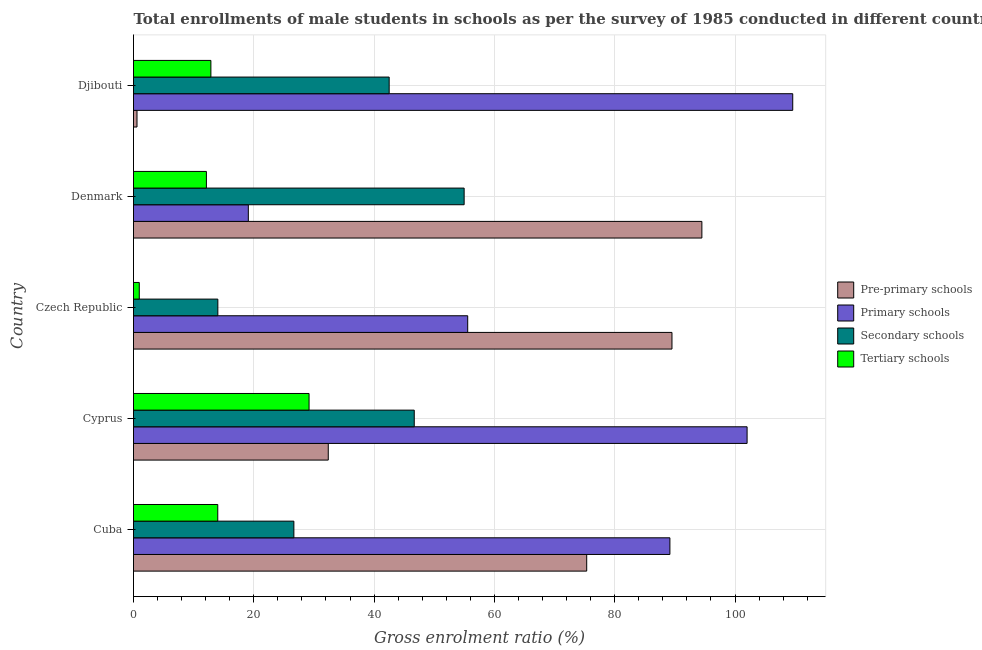Are the number of bars on each tick of the Y-axis equal?
Give a very brief answer. Yes. How many bars are there on the 5th tick from the top?
Provide a succinct answer. 4. What is the label of the 5th group of bars from the top?
Offer a terse response. Cuba. What is the gross enrolment ratio(male) in primary schools in Cyprus?
Make the answer very short. 102.01. Across all countries, what is the maximum gross enrolment ratio(male) in primary schools?
Make the answer very short. 109.6. Across all countries, what is the minimum gross enrolment ratio(male) in tertiary schools?
Offer a very short reply. 0.96. In which country was the gross enrolment ratio(male) in primary schools minimum?
Ensure brevity in your answer.  Denmark. What is the total gross enrolment ratio(male) in secondary schools in the graph?
Provide a succinct answer. 184.83. What is the difference between the gross enrolment ratio(male) in pre-primary schools in Cyprus and that in Djibouti?
Your answer should be very brief. 31.8. What is the difference between the gross enrolment ratio(male) in primary schools in Czech Republic and the gross enrolment ratio(male) in tertiary schools in Cyprus?
Ensure brevity in your answer.  26.37. What is the average gross enrolment ratio(male) in secondary schools per country?
Keep it short and to the point. 36.97. What is the difference between the gross enrolment ratio(male) in pre-primary schools and gross enrolment ratio(male) in primary schools in Cuba?
Make the answer very short. -13.83. In how many countries, is the gross enrolment ratio(male) in pre-primary schools greater than 84 %?
Make the answer very short. 2. What is the ratio of the gross enrolment ratio(male) in tertiary schools in Cuba to that in Czech Republic?
Make the answer very short. 14.6. Is the gross enrolment ratio(male) in secondary schools in Cyprus less than that in Czech Republic?
Provide a succinct answer. No. What is the difference between the highest and the second highest gross enrolment ratio(male) in pre-primary schools?
Provide a succinct answer. 4.97. What is the difference between the highest and the lowest gross enrolment ratio(male) in primary schools?
Offer a terse response. 90.51. What does the 4th bar from the top in Djibouti represents?
Ensure brevity in your answer.  Pre-primary schools. What does the 1st bar from the bottom in Djibouti represents?
Provide a succinct answer. Pre-primary schools. Is it the case that in every country, the sum of the gross enrolment ratio(male) in pre-primary schools and gross enrolment ratio(male) in primary schools is greater than the gross enrolment ratio(male) in secondary schools?
Ensure brevity in your answer.  Yes. Are all the bars in the graph horizontal?
Provide a short and direct response. Yes. Are the values on the major ticks of X-axis written in scientific E-notation?
Provide a succinct answer. No. What is the title of the graph?
Your answer should be very brief. Total enrollments of male students in schools as per the survey of 1985 conducted in different countries. What is the label or title of the X-axis?
Provide a succinct answer. Gross enrolment ratio (%). What is the label or title of the Y-axis?
Make the answer very short. Country. What is the Gross enrolment ratio (%) in Pre-primary schools in Cuba?
Give a very brief answer. 75.34. What is the Gross enrolment ratio (%) of Primary schools in Cuba?
Offer a terse response. 89.18. What is the Gross enrolment ratio (%) in Secondary schools in Cuba?
Give a very brief answer. 26.66. What is the Gross enrolment ratio (%) of Tertiary schools in Cuba?
Make the answer very short. 14.01. What is the Gross enrolment ratio (%) of Pre-primary schools in Cyprus?
Provide a short and direct response. 32.38. What is the Gross enrolment ratio (%) in Primary schools in Cyprus?
Your answer should be very brief. 102.01. What is the Gross enrolment ratio (%) in Secondary schools in Cyprus?
Keep it short and to the point. 46.67. What is the Gross enrolment ratio (%) in Tertiary schools in Cyprus?
Give a very brief answer. 29.19. What is the Gross enrolment ratio (%) of Pre-primary schools in Czech Republic?
Your answer should be very brief. 89.52. What is the Gross enrolment ratio (%) in Primary schools in Czech Republic?
Keep it short and to the point. 55.56. What is the Gross enrolment ratio (%) of Secondary schools in Czech Republic?
Offer a terse response. 14.02. What is the Gross enrolment ratio (%) in Tertiary schools in Czech Republic?
Provide a short and direct response. 0.96. What is the Gross enrolment ratio (%) of Pre-primary schools in Denmark?
Offer a terse response. 94.49. What is the Gross enrolment ratio (%) in Primary schools in Denmark?
Make the answer very short. 19.09. What is the Gross enrolment ratio (%) of Secondary schools in Denmark?
Offer a very short reply. 54.97. What is the Gross enrolment ratio (%) of Tertiary schools in Denmark?
Offer a terse response. 12.12. What is the Gross enrolment ratio (%) in Pre-primary schools in Djibouti?
Provide a succinct answer. 0.58. What is the Gross enrolment ratio (%) in Primary schools in Djibouti?
Make the answer very short. 109.6. What is the Gross enrolment ratio (%) of Secondary schools in Djibouti?
Make the answer very short. 42.5. What is the Gross enrolment ratio (%) in Tertiary schools in Djibouti?
Give a very brief answer. 12.87. Across all countries, what is the maximum Gross enrolment ratio (%) in Pre-primary schools?
Provide a succinct answer. 94.49. Across all countries, what is the maximum Gross enrolment ratio (%) in Primary schools?
Provide a short and direct response. 109.6. Across all countries, what is the maximum Gross enrolment ratio (%) of Secondary schools?
Offer a very short reply. 54.97. Across all countries, what is the maximum Gross enrolment ratio (%) of Tertiary schools?
Your answer should be very brief. 29.19. Across all countries, what is the minimum Gross enrolment ratio (%) of Pre-primary schools?
Give a very brief answer. 0.58. Across all countries, what is the minimum Gross enrolment ratio (%) in Primary schools?
Offer a very short reply. 19.09. Across all countries, what is the minimum Gross enrolment ratio (%) in Secondary schools?
Keep it short and to the point. 14.02. Across all countries, what is the minimum Gross enrolment ratio (%) in Tertiary schools?
Offer a very short reply. 0.96. What is the total Gross enrolment ratio (%) in Pre-primary schools in the graph?
Your response must be concise. 292.31. What is the total Gross enrolment ratio (%) of Primary schools in the graph?
Your answer should be very brief. 375.43. What is the total Gross enrolment ratio (%) of Secondary schools in the graph?
Make the answer very short. 184.83. What is the total Gross enrolment ratio (%) in Tertiary schools in the graph?
Your response must be concise. 69.14. What is the difference between the Gross enrolment ratio (%) in Pre-primary schools in Cuba and that in Cyprus?
Offer a terse response. 42.96. What is the difference between the Gross enrolment ratio (%) of Primary schools in Cuba and that in Cyprus?
Your answer should be very brief. -12.83. What is the difference between the Gross enrolment ratio (%) in Secondary schools in Cuba and that in Cyprus?
Offer a terse response. -20.01. What is the difference between the Gross enrolment ratio (%) of Tertiary schools in Cuba and that in Cyprus?
Provide a short and direct response. -15.18. What is the difference between the Gross enrolment ratio (%) in Pre-primary schools in Cuba and that in Czech Republic?
Your response must be concise. -14.18. What is the difference between the Gross enrolment ratio (%) in Primary schools in Cuba and that in Czech Republic?
Your response must be concise. 33.62. What is the difference between the Gross enrolment ratio (%) in Secondary schools in Cuba and that in Czech Republic?
Your answer should be compact. 12.64. What is the difference between the Gross enrolment ratio (%) in Tertiary schools in Cuba and that in Czech Republic?
Give a very brief answer. 13.05. What is the difference between the Gross enrolment ratio (%) in Pre-primary schools in Cuba and that in Denmark?
Ensure brevity in your answer.  -19.15. What is the difference between the Gross enrolment ratio (%) in Primary schools in Cuba and that in Denmark?
Your response must be concise. 70.09. What is the difference between the Gross enrolment ratio (%) in Secondary schools in Cuba and that in Denmark?
Ensure brevity in your answer.  -28.31. What is the difference between the Gross enrolment ratio (%) in Tertiary schools in Cuba and that in Denmark?
Your response must be concise. 1.89. What is the difference between the Gross enrolment ratio (%) of Pre-primary schools in Cuba and that in Djibouti?
Ensure brevity in your answer.  74.76. What is the difference between the Gross enrolment ratio (%) in Primary schools in Cuba and that in Djibouti?
Your answer should be very brief. -20.42. What is the difference between the Gross enrolment ratio (%) in Secondary schools in Cuba and that in Djibouti?
Your answer should be compact. -15.84. What is the difference between the Gross enrolment ratio (%) of Pre-primary schools in Cyprus and that in Czech Republic?
Your response must be concise. -57.14. What is the difference between the Gross enrolment ratio (%) in Primary schools in Cyprus and that in Czech Republic?
Your answer should be compact. 46.45. What is the difference between the Gross enrolment ratio (%) in Secondary schools in Cyprus and that in Czech Republic?
Keep it short and to the point. 32.65. What is the difference between the Gross enrolment ratio (%) of Tertiary schools in Cyprus and that in Czech Republic?
Provide a short and direct response. 28.23. What is the difference between the Gross enrolment ratio (%) of Pre-primary schools in Cyprus and that in Denmark?
Offer a terse response. -62.11. What is the difference between the Gross enrolment ratio (%) of Primary schools in Cyprus and that in Denmark?
Your answer should be compact. 82.92. What is the difference between the Gross enrolment ratio (%) of Secondary schools in Cyprus and that in Denmark?
Provide a short and direct response. -8.29. What is the difference between the Gross enrolment ratio (%) of Tertiary schools in Cyprus and that in Denmark?
Your answer should be compact. 17.07. What is the difference between the Gross enrolment ratio (%) of Pre-primary schools in Cyprus and that in Djibouti?
Your answer should be compact. 31.8. What is the difference between the Gross enrolment ratio (%) in Primary schools in Cyprus and that in Djibouti?
Provide a succinct answer. -7.59. What is the difference between the Gross enrolment ratio (%) of Secondary schools in Cyprus and that in Djibouti?
Make the answer very short. 4.17. What is the difference between the Gross enrolment ratio (%) in Tertiary schools in Cyprus and that in Djibouti?
Provide a short and direct response. 16.32. What is the difference between the Gross enrolment ratio (%) of Pre-primary schools in Czech Republic and that in Denmark?
Give a very brief answer. -4.97. What is the difference between the Gross enrolment ratio (%) in Primary schools in Czech Republic and that in Denmark?
Your response must be concise. 36.47. What is the difference between the Gross enrolment ratio (%) in Secondary schools in Czech Republic and that in Denmark?
Your answer should be very brief. -40.95. What is the difference between the Gross enrolment ratio (%) of Tertiary schools in Czech Republic and that in Denmark?
Your answer should be compact. -11.16. What is the difference between the Gross enrolment ratio (%) in Pre-primary schools in Czech Republic and that in Djibouti?
Your answer should be compact. 88.94. What is the difference between the Gross enrolment ratio (%) in Primary schools in Czech Republic and that in Djibouti?
Provide a short and direct response. -54.04. What is the difference between the Gross enrolment ratio (%) in Secondary schools in Czech Republic and that in Djibouti?
Provide a succinct answer. -28.48. What is the difference between the Gross enrolment ratio (%) of Tertiary schools in Czech Republic and that in Djibouti?
Your answer should be compact. -11.91. What is the difference between the Gross enrolment ratio (%) in Pre-primary schools in Denmark and that in Djibouti?
Make the answer very short. 93.91. What is the difference between the Gross enrolment ratio (%) in Primary schools in Denmark and that in Djibouti?
Provide a short and direct response. -90.51. What is the difference between the Gross enrolment ratio (%) of Secondary schools in Denmark and that in Djibouti?
Ensure brevity in your answer.  12.46. What is the difference between the Gross enrolment ratio (%) of Tertiary schools in Denmark and that in Djibouti?
Your answer should be compact. -0.75. What is the difference between the Gross enrolment ratio (%) of Pre-primary schools in Cuba and the Gross enrolment ratio (%) of Primary schools in Cyprus?
Your answer should be very brief. -26.67. What is the difference between the Gross enrolment ratio (%) of Pre-primary schools in Cuba and the Gross enrolment ratio (%) of Secondary schools in Cyprus?
Provide a short and direct response. 28.67. What is the difference between the Gross enrolment ratio (%) of Pre-primary schools in Cuba and the Gross enrolment ratio (%) of Tertiary schools in Cyprus?
Ensure brevity in your answer.  46.16. What is the difference between the Gross enrolment ratio (%) of Primary schools in Cuba and the Gross enrolment ratio (%) of Secondary schools in Cyprus?
Your answer should be compact. 42.5. What is the difference between the Gross enrolment ratio (%) in Primary schools in Cuba and the Gross enrolment ratio (%) in Tertiary schools in Cyprus?
Ensure brevity in your answer.  59.99. What is the difference between the Gross enrolment ratio (%) of Secondary schools in Cuba and the Gross enrolment ratio (%) of Tertiary schools in Cyprus?
Offer a very short reply. -2.52. What is the difference between the Gross enrolment ratio (%) in Pre-primary schools in Cuba and the Gross enrolment ratio (%) in Primary schools in Czech Republic?
Offer a terse response. 19.78. What is the difference between the Gross enrolment ratio (%) in Pre-primary schools in Cuba and the Gross enrolment ratio (%) in Secondary schools in Czech Republic?
Offer a terse response. 61.32. What is the difference between the Gross enrolment ratio (%) in Pre-primary schools in Cuba and the Gross enrolment ratio (%) in Tertiary schools in Czech Republic?
Offer a terse response. 74.38. What is the difference between the Gross enrolment ratio (%) of Primary schools in Cuba and the Gross enrolment ratio (%) of Secondary schools in Czech Republic?
Make the answer very short. 75.15. What is the difference between the Gross enrolment ratio (%) of Primary schools in Cuba and the Gross enrolment ratio (%) of Tertiary schools in Czech Republic?
Provide a short and direct response. 88.22. What is the difference between the Gross enrolment ratio (%) of Secondary schools in Cuba and the Gross enrolment ratio (%) of Tertiary schools in Czech Republic?
Offer a very short reply. 25.7. What is the difference between the Gross enrolment ratio (%) in Pre-primary schools in Cuba and the Gross enrolment ratio (%) in Primary schools in Denmark?
Your response must be concise. 56.25. What is the difference between the Gross enrolment ratio (%) of Pre-primary schools in Cuba and the Gross enrolment ratio (%) of Secondary schools in Denmark?
Offer a terse response. 20.37. What is the difference between the Gross enrolment ratio (%) in Pre-primary schools in Cuba and the Gross enrolment ratio (%) in Tertiary schools in Denmark?
Your response must be concise. 63.22. What is the difference between the Gross enrolment ratio (%) of Primary schools in Cuba and the Gross enrolment ratio (%) of Secondary schools in Denmark?
Keep it short and to the point. 34.21. What is the difference between the Gross enrolment ratio (%) of Primary schools in Cuba and the Gross enrolment ratio (%) of Tertiary schools in Denmark?
Give a very brief answer. 77.06. What is the difference between the Gross enrolment ratio (%) of Secondary schools in Cuba and the Gross enrolment ratio (%) of Tertiary schools in Denmark?
Ensure brevity in your answer.  14.54. What is the difference between the Gross enrolment ratio (%) of Pre-primary schools in Cuba and the Gross enrolment ratio (%) of Primary schools in Djibouti?
Give a very brief answer. -34.25. What is the difference between the Gross enrolment ratio (%) in Pre-primary schools in Cuba and the Gross enrolment ratio (%) in Secondary schools in Djibouti?
Offer a terse response. 32.84. What is the difference between the Gross enrolment ratio (%) of Pre-primary schools in Cuba and the Gross enrolment ratio (%) of Tertiary schools in Djibouti?
Keep it short and to the point. 62.48. What is the difference between the Gross enrolment ratio (%) of Primary schools in Cuba and the Gross enrolment ratio (%) of Secondary schools in Djibouti?
Provide a succinct answer. 46.67. What is the difference between the Gross enrolment ratio (%) of Primary schools in Cuba and the Gross enrolment ratio (%) of Tertiary schools in Djibouti?
Your response must be concise. 76.31. What is the difference between the Gross enrolment ratio (%) of Secondary schools in Cuba and the Gross enrolment ratio (%) of Tertiary schools in Djibouti?
Provide a short and direct response. 13.8. What is the difference between the Gross enrolment ratio (%) in Pre-primary schools in Cyprus and the Gross enrolment ratio (%) in Primary schools in Czech Republic?
Make the answer very short. -23.18. What is the difference between the Gross enrolment ratio (%) in Pre-primary schools in Cyprus and the Gross enrolment ratio (%) in Secondary schools in Czech Republic?
Ensure brevity in your answer.  18.36. What is the difference between the Gross enrolment ratio (%) of Pre-primary schools in Cyprus and the Gross enrolment ratio (%) of Tertiary schools in Czech Republic?
Offer a terse response. 31.42. What is the difference between the Gross enrolment ratio (%) in Primary schools in Cyprus and the Gross enrolment ratio (%) in Secondary schools in Czech Republic?
Offer a terse response. 87.99. What is the difference between the Gross enrolment ratio (%) of Primary schools in Cyprus and the Gross enrolment ratio (%) of Tertiary schools in Czech Republic?
Your response must be concise. 101.05. What is the difference between the Gross enrolment ratio (%) in Secondary schools in Cyprus and the Gross enrolment ratio (%) in Tertiary schools in Czech Republic?
Ensure brevity in your answer.  45.71. What is the difference between the Gross enrolment ratio (%) of Pre-primary schools in Cyprus and the Gross enrolment ratio (%) of Primary schools in Denmark?
Make the answer very short. 13.29. What is the difference between the Gross enrolment ratio (%) of Pre-primary schools in Cyprus and the Gross enrolment ratio (%) of Secondary schools in Denmark?
Make the answer very short. -22.59. What is the difference between the Gross enrolment ratio (%) of Pre-primary schools in Cyprus and the Gross enrolment ratio (%) of Tertiary schools in Denmark?
Give a very brief answer. 20.26. What is the difference between the Gross enrolment ratio (%) of Primary schools in Cyprus and the Gross enrolment ratio (%) of Secondary schools in Denmark?
Keep it short and to the point. 47.04. What is the difference between the Gross enrolment ratio (%) of Primary schools in Cyprus and the Gross enrolment ratio (%) of Tertiary schools in Denmark?
Your answer should be very brief. 89.89. What is the difference between the Gross enrolment ratio (%) in Secondary schools in Cyprus and the Gross enrolment ratio (%) in Tertiary schools in Denmark?
Your response must be concise. 34.55. What is the difference between the Gross enrolment ratio (%) of Pre-primary schools in Cyprus and the Gross enrolment ratio (%) of Primary schools in Djibouti?
Your answer should be very brief. -77.22. What is the difference between the Gross enrolment ratio (%) in Pre-primary schools in Cyprus and the Gross enrolment ratio (%) in Secondary schools in Djibouti?
Your response must be concise. -10.13. What is the difference between the Gross enrolment ratio (%) of Pre-primary schools in Cyprus and the Gross enrolment ratio (%) of Tertiary schools in Djibouti?
Make the answer very short. 19.51. What is the difference between the Gross enrolment ratio (%) in Primary schools in Cyprus and the Gross enrolment ratio (%) in Secondary schools in Djibouti?
Keep it short and to the point. 59.5. What is the difference between the Gross enrolment ratio (%) in Primary schools in Cyprus and the Gross enrolment ratio (%) in Tertiary schools in Djibouti?
Make the answer very short. 89.14. What is the difference between the Gross enrolment ratio (%) of Secondary schools in Cyprus and the Gross enrolment ratio (%) of Tertiary schools in Djibouti?
Give a very brief answer. 33.81. What is the difference between the Gross enrolment ratio (%) in Pre-primary schools in Czech Republic and the Gross enrolment ratio (%) in Primary schools in Denmark?
Your answer should be compact. 70.43. What is the difference between the Gross enrolment ratio (%) in Pre-primary schools in Czech Republic and the Gross enrolment ratio (%) in Secondary schools in Denmark?
Offer a terse response. 34.55. What is the difference between the Gross enrolment ratio (%) in Pre-primary schools in Czech Republic and the Gross enrolment ratio (%) in Tertiary schools in Denmark?
Make the answer very short. 77.4. What is the difference between the Gross enrolment ratio (%) in Primary schools in Czech Republic and the Gross enrolment ratio (%) in Secondary schools in Denmark?
Give a very brief answer. 0.59. What is the difference between the Gross enrolment ratio (%) in Primary schools in Czech Republic and the Gross enrolment ratio (%) in Tertiary schools in Denmark?
Your answer should be compact. 43.44. What is the difference between the Gross enrolment ratio (%) in Secondary schools in Czech Republic and the Gross enrolment ratio (%) in Tertiary schools in Denmark?
Provide a short and direct response. 1.9. What is the difference between the Gross enrolment ratio (%) in Pre-primary schools in Czech Republic and the Gross enrolment ratio (%) in Primary schools in Djibouti?
Your answer should be very brief. -20.08. What is the difference between the Gross enrolment ratio (%) in Pre-primary schools in Czech Republic and the Gross enrolment ratio (%) in Secondary schools in Djibouti?
Ensure brevity in your answer.  47.01. What is the difference between the Gross enrolment ratio (%) in Pre-primary schools in Czech Republic and the Gross enrolment ratio (%) in Tertiary schools in Djibouti?
Provide a short and direct response. 76.65. What is the difference between the Gross enrolment ratio (%) of Primary schools in Czech Republic and the Gross enrolment ratio (%) of Secondary schools in Djibouti?
Offer a terse response. 13.05. What is the difference between the Gross enrolment ratio (%) of Primary schools in Czech Republic and the Gross enrolment ratio (%) of Tertiary schools in Djibouti?
Provide a short and direct response. 42.69. What is the difference between the Gross enrolment ratio (%) in Secondary schools in Czech Republic and the Gross enrolment ratio (%) in Tertiary schools in Djibouti?
Your response must be concise. 1.16. What is the difference between the Gross enrolment ratio (%) in Pre-primary schools in Denmark and the Gross enrolment ratio (%) in Primary schools in Djibouti?
Your response must be concise. -15.1. What is the difference between the Gross enrolment ratio (%) in Pre-primary schools in Denmark and the Gross enrolment ratio (%) in Secondary schools in Djibouti?
Your response must be concise. 51.99. What is the difference between the Gross enrolment ratio (%) in Pre-primary schools in Denmark and the Gross enrolment ratio (%) in Tertiary schools in Djibouti?
Make the answer very short. 81.62. What is the difference between the Gross enrolment ratio (%) of Primary schools in Denmark and the Gross enrolment ratio (%) of Secondary schools in Djibouti?
Your response must be concise. -23.42. What is the difference between the Gross enrolment ratio (%) of Primary schools in Denmark and the Gross enrolment ratio (%) of Tertiary schools in Djibouti?
Provide a short and direct response. 6.22. What is the difference between the Gross enrolment ratio (%) of Secondary schools in Denmark and the Gross enrolment ratio (%) of Tertiary schools in Djibouti?
Provide a succinct answer. 42.1. What is the average Gross enrolment ratio (%) in Pre-primary schools per country?
Make the answer very short. 58.46. What is the average Gross enrolment ratio (%) in Primary schools per country?
Provide a short and direct response. 75.09. What is the average Gross enrolment ratio (%) in Secondary schools per country?
Ensure brevity in your answer.  36.97. What is the average Gross enrolment ratio (%) of Tertiary schools per country?
Provide a succinct answer. 13.83. What is the difference between the Gross enrolment ratio (%) of Pre-primary schools and Gross enrolment ratio (%) of Primary schools in Cuba?
Give a very brief answer. -13.83. What is the difference between the Gross enrolment ratio (%) in Pre-primary schools and Gross enrolment ratio (%) in Secondary schools in Cuba?
Make the answer very short. 48.68. What is the difference between the Gross enrolment ratio (%) of Pre-primary schools and Gross enrolment ratio (%) of Tertiary schools in Cuba?
Your answer should be very brief. 61.33. What is the difference between the Gross enrolment ratio (%) of Primary schools and Gross enrolment ratio (%) of Secondary schools in Cuba?
Keep it short and to the point. 62.51. What is the difference between the Gross enrolment ratio (%) in Primary schools and Gross enrolment ratio (%) in Tertiary schools in Cuba?
Offer a very short reply. 75.17. What is the difference between the Gross enrolment ratio (%) in Secondary schools and Gross enrolment ratio (%) in Tertiary schools in Cuba?
Your answer should be very brief. 12.65. What is the difference between the Gross enrolment ratio (%) in Pre-primary schools and Gross enrolment ratio (%) in Primary schools in Cyprus?
Your response must be concise. -69.63. What is the difference between the Gross enrolment ratio (%) of Pre-primary schools and Gross enrolment ratio (%) of Secondary schools in Cyprus?
Ensure brevity in your answer.  -14.29. What is the difference between the Gross enrolment ratio (%) in Pre-primary schools and Gross enrolment ratio (%) in Tertiary schools in Cyprus?
Provide a short and direct response. 3.19. What is the difference between the Gross enrolment ratio (%) of Primary schools and Gross enrolment ratio (%) of Secondary schools in Cyprus?
Ensure brevity in your answer.  55.34. What is the difference between the Gross enrolment ratio (%) of Primary schools and Gross enrolment ratio (%) of Tertiary schools in Cyprus?
Give a very brief answer. 72.82. What is the difference between the Gross enrolment ratio (%) in Secondary schools and Gross enrolment ratio (%) in Tertiary schools in Cyprus?
Give a very brief answer. 17.49. What is the difference between the Gross enrolment ratio (%) in Pre-primary schools and Gross enrolment ratio (%) in Primary schools in Czech Republic?
Keep it short and to the point. 33.96. What is the difference between the Gross enrolment ratio (%) of Pre-primary schools and Gross enrolment ratio (%) of Secondary schools in Czech Republic?
Ensure brevity in your answer.  75.5. What is the difference between the Gross enrolment ratio (%) of Pre-primary schools and Gross enrolment ratio (%) of Tertiary schools in Czech Republic?
Make the answer very short. 88.56. What is the difference between the Gross enrolment ratio (%) in Primary schools and Gross enrolment ratio (%) in Secondary schools in Czech Republic?
Your response must be concise. 41.54. What is the difference between the Gross enrolment ratio (%) in Primary schools and Gross enrolment ratio (%) in Tertiary schools in Czech Republic?
Offer a very short reply. 54.6. What is the difference between the Gross enrolment ratio (%) of Secondary schools and Gross enrolment ratio (%) of Tertiary schools in Czech Republic?
Make the answer very short. 13.06. What is the difference between the Gross enrolment ratio (%) in Pre-primary schools and Gross enrolment ratio (%) in Primary schools in Denmark?
Your answer should be very brief. 75.4. What is the difference between the Gross enrolment ratio (%) in Pre-primary schools and Gross enrolment ratio (%) in Secondary schools in Denmark?
Your answer should be very brief. 39.52. What is the difference between the Gross enrolment ratio (%) of Pre-primary schools and Gross enrolment ratio (%) of Tertiary schools in Denmark?
Keep it short and to the point. 82.37. What is the difference between the Gross enrolment ratio (%) in Primary schools and Gross enrolment ratio (%) in Secondary schools in Denmark?
Offer a terse response. -35.88. What is the difference between the Gross enrolment ratio (%) of Primary schools and Gross enrolment ratio (%) of Tertiary schools in Denmark?
Your response must be concise. 6.97. What is the difference between the Gross enrolment ratio (%) in Secondary schools and Gross enrolment ratio (%) in Tertiary schools in Denmark?
Provide a succinct answer. 42.85. What is the difference between the Gross enrolment ratio (%) of Pre-primary schools and Gross enrolment ratio (%) of Primary schools in Djibouti?
Offer a very short reply. -109.02. What is the difference between the Gross enrolment ratio (%) of Pre-primary schools and Gross enrolment ratio (%) of Secondary schools in Djibouti?
Ensure brevity in your answer.  -41.92. What is the difference between the Gross enrolment ratio (%) in Pre-primary schools and Gross enrolment ratio (%) in Tertiary schools in Djibouti?
Provide a short and direct response. -12.29. What is the difference between the Gross enrolment ratio (%) of Primary schools and Gross enrolment ratio (%) of Secondary schools in Djibouti?
Provide a short and direct response. 67.09. What is the difference between the Gross enrolment ratio (%) in Primary schools and Gross enrolment ratio (%) in Tertiary schools in Djibouti?
Ensure brevity in your answer.  96.73. What is the difference between the Gross enrolment ratio (%) in Secondary schools and Gross enrolment ratio (%) in Tertiary schools in Djibouti?
Give a very brief answer. 29.64. What is the ratio of the Gross enrolment ratio (%) of Pre-primary schools in Cuba to that in Cyprus?
Offer a terse response. 2.33. What is the ratio of the Gross enrolment ratio (%) of Primary schools in Cuba to that in Cyprus?
Your answer should be compact. 0.87. What is the ratio of the Gross enrolment ratio (%) in Secondary schools in Cuba to that in Cyprus?
Your response must be concise. 0.57. What is the ratio of the Gross enrolment ratio (%) in Tertiary schools in Cuba to that in Cyprus?
Give a very brief answer. 0.48. What is the ratio of the Gross enrolment ratio (%) of Pre-primary schools in Cuba to that in Czech Republic?
Your answer should be very brief. 0.84. What is the ratio of the Gross enrolment ratio (%) of Primary schools in Cuba to that in Czech Republic?
Keep it short and to the point. 1.61. What is the ratio of the Gross enrolment ratio (%) in Secondary schools in Cuba to that in Czech Republic?
Your answer should be compact. 1.9. What is the ratio of the Gross enrolment ratio (%) of Tertiary schools in Cuba to that in Czech Republic?
Your answer should be compact. 14.6. What is the ratio of the Gross enrolment ratio (%) in Pre-primary schools in Cuba to that in Denmark?
Offer a terse response. 0.8. What is the ratio of the Gross enrolment ratio (%) in Primary schools in Cuba to that in Denmark?
Make the answer very short. 4.67. What is the ratio of the Gross enrolment ratio (%) of Secondary schools in Cuba to that in Denmark?
Provide a succinct answer. 0.48. What is the ratio of the Gross enrolment ratio (%) of Tertiary schools in Cuba to that in Denmark?
Ensure brevity in your answer.  1.16. What is the ratio of the Gross enrolment ratio (%) of Pre-primary schools in Cuba to that in Djibouti?
Your answer should be compact. 129.89. What is the ratio of the Gross enrolment ratio (%) of Primary schools in Cuba to that in Djibouti?
Make the answer very short. 0.81. What is the ratio of the Gross enrolment ratio (%) in Secondary schools in Cuba to that in Djibouti?
Your answer should be compact. 0.63. What is the ratio of the Gross enrolment ratio (%) in Tertiary schools in Cuba to that in Djibouti?
Provide a succinct answer. 1.09. What is the ratio of the Gross enrolment ratio (%) of Pre-primary schools in Cyprus to that in Czech Republic?
Offer a very short reply. 0.36. What is the ratio of the Gross enrolment ratio (%) of Primary schools in Cyprus to that in Czech Republic?
Offer a very short reply. 1.84. What is the ratio of the Gross enrolment ratio (%) of Secondary schools in Cyprus to that in Czech Republic?
Make the answer very short. 3.33. What is the ratio of the Gross enrolment ratio (%) in Tertiary schools in Cyprus to that in Czech Republic?
Keep it short and to the point. 30.42. What is the ratio of the Gross enrolment ratio (%) of Pre-primary schools in Cyprus to that in Denmark?
Your answer should be very brief. 0.34. What is the ratio of the Gross enrolment ratio (%) in Primary schools in Cyprus to that in Denmark?
Provide a succinct answer. 5.34. What is the ratio of the Gross enrolment ratio (%) of Secondary schools in Cyprus to that in Denmark?
Your answer should be very brief. 0.85. What is the ratio of the Gross enrolment ratio (%) in Tertiary schools in Cyprus to that in Denmark?
Ensure brevity in your answer.  2.41. What is the ratio of the Gross enrolment ratio (%) of Pre-primary schools in Cyprus to that in Djibouti?
Your answer should be very brief. 55.82. What is the ratio of the Gross enrolment ratio (%) of Primary schools in Cyprus to that in Djibouti?
Ensure brevity in your answer.  0.93. What is the ratio of the Gross enrolment ratio (%) of Secondary schools in Cyprus to that in Djibouti?
Make the answer very short. 1.1. What is the ratio of the Gross enrolment ratio (%) in Tertiary schools in Cyprus to that in Djibouti?
Offer a terse response. 2.27. What is the ratio of the Gross enrolment ratio (%) in Pre-primary schools in Czech Republic to that in Denmark?
Your answer should be very brief. 0.95. What is the ratio of the Gross enrolment ratio (%) of Primary schools in Czech Republic to that in Denmark?
Offer a very short reply. 2.91. What is the ratio of the Gross enrolment ratio (%) of Secondary schools in Czech Republic to that in Denmark?
Your answer should be compact. 0.26. What is the ratio of the Gross enrolment ratio (%) of Tertiary schools in Czech Republic to that in Denmark?
Give a very brief answer. 0.08. What is the ratio of the Gross enrolment ratio (%) in Pre-primary schools in Czech Republic to that in Djibouti?
Offer a very short reply. 154.33. What is the ratio of the Gross enrolment ratio (%) of Primary schools in Czech Republic to that in Djibouti?
Your answer should be compact. 0.51. What is the ratio of the Gross enrolment ratio (%) of Secondary schools in Czech Republic to that in Djibouti?
Offer a very short reply. 0.33. What is the ratio of the Gross enrolment ratio (%) in Tertiary schools in Czech Republic to that in Djibouti?
Ensure brevity in your answer.  0.07. What is the ratio of the Gross enrolment ratio (%) in Pre-primary schools in Denmark to that in Djibouti?
Your answer should be compact. 162.9. What is the ratio of the Gross enrolment ratio (%) of Primary schools in Denmark to that in Djibouti?
Give a very brief answer. 0.17. What is the ratio of the Gross enrolment ratio (%) of Secondary schools in Denmark to that in Djibouti?
Ensure brevity in your answer.  1.29. What is the ratio of the Gross enrolment ratio (%) of Tertiary schools in Denmark to that in Djibouti?
Your response must be concise. 0.94. What is the difference between the highest and the second highest Gross enrolment ratio (%) in Pre-primary schools?
Your response must be concise. 4.97. What is the difference between the highest and the second highest Gross enrolment ratio (%) in Primary schools?
Offer a very short reply. 7.59. What is the difference between the highest and the second highest Gross enrolment ratio (%) in Secondary schools?
Your answer should be very brief. 8.29. What is the difference between the highest and the second highest Gross enrolment ratio (%) in Tertiary schools?
Keep it short and to the point. 15.18. What is the difference between the highest and the lowest Gross enrolment ratio (%) of Pre-primary schools?
Ensure brevity in your answer.  93.91. What is the difference between the highest and the lowest Gross enrolment ratio (%) in Primary schools?
Keep it short and to the point. 90.51. What is the difference between the highest and the lowest Gross enrolment ratio (%) of Secondary schools?
Ensure brevity in your answer.  40.95. What is the difference between the highest and the lowest Gross enrolment ratio (%) of Tertiary schools?
Offer a very short reply. 28.23. 